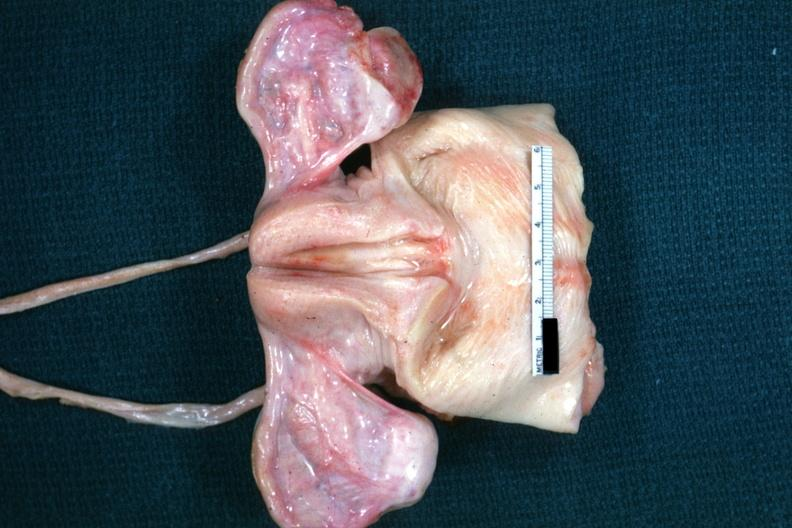what are non functional in this case of vacant sella but externally i can see nothing?
Answer the question using a single word or phrase. Truly normal ovaries 